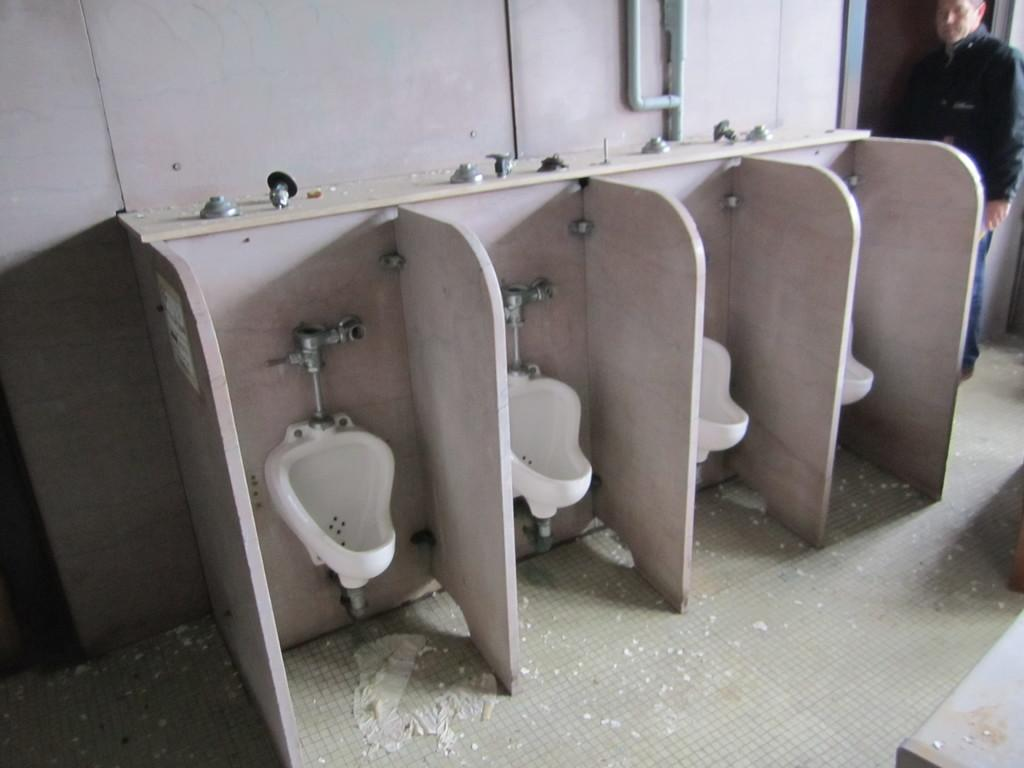What type of toilets are visible in the image? There are urinary toilets in the image. Can you describe the person's position in the image? There is a person at the door in the image. What type of metal is used to make the lead in the image? There is no lead or metal present in the image; it features urinary toilets and a person at the door. What hobbies does the person at the door have, as depicted in the image? The image does not provide information about the person's hobbies; it only shows their position at the door. 